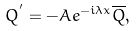Convert formula to latex. <formula><loc_0><loc_0><loc_500><loc_500>Q ^ { ^ { \prime } } = - A e ^ { - i \lambda x } \overline { Q } ,</formula> 